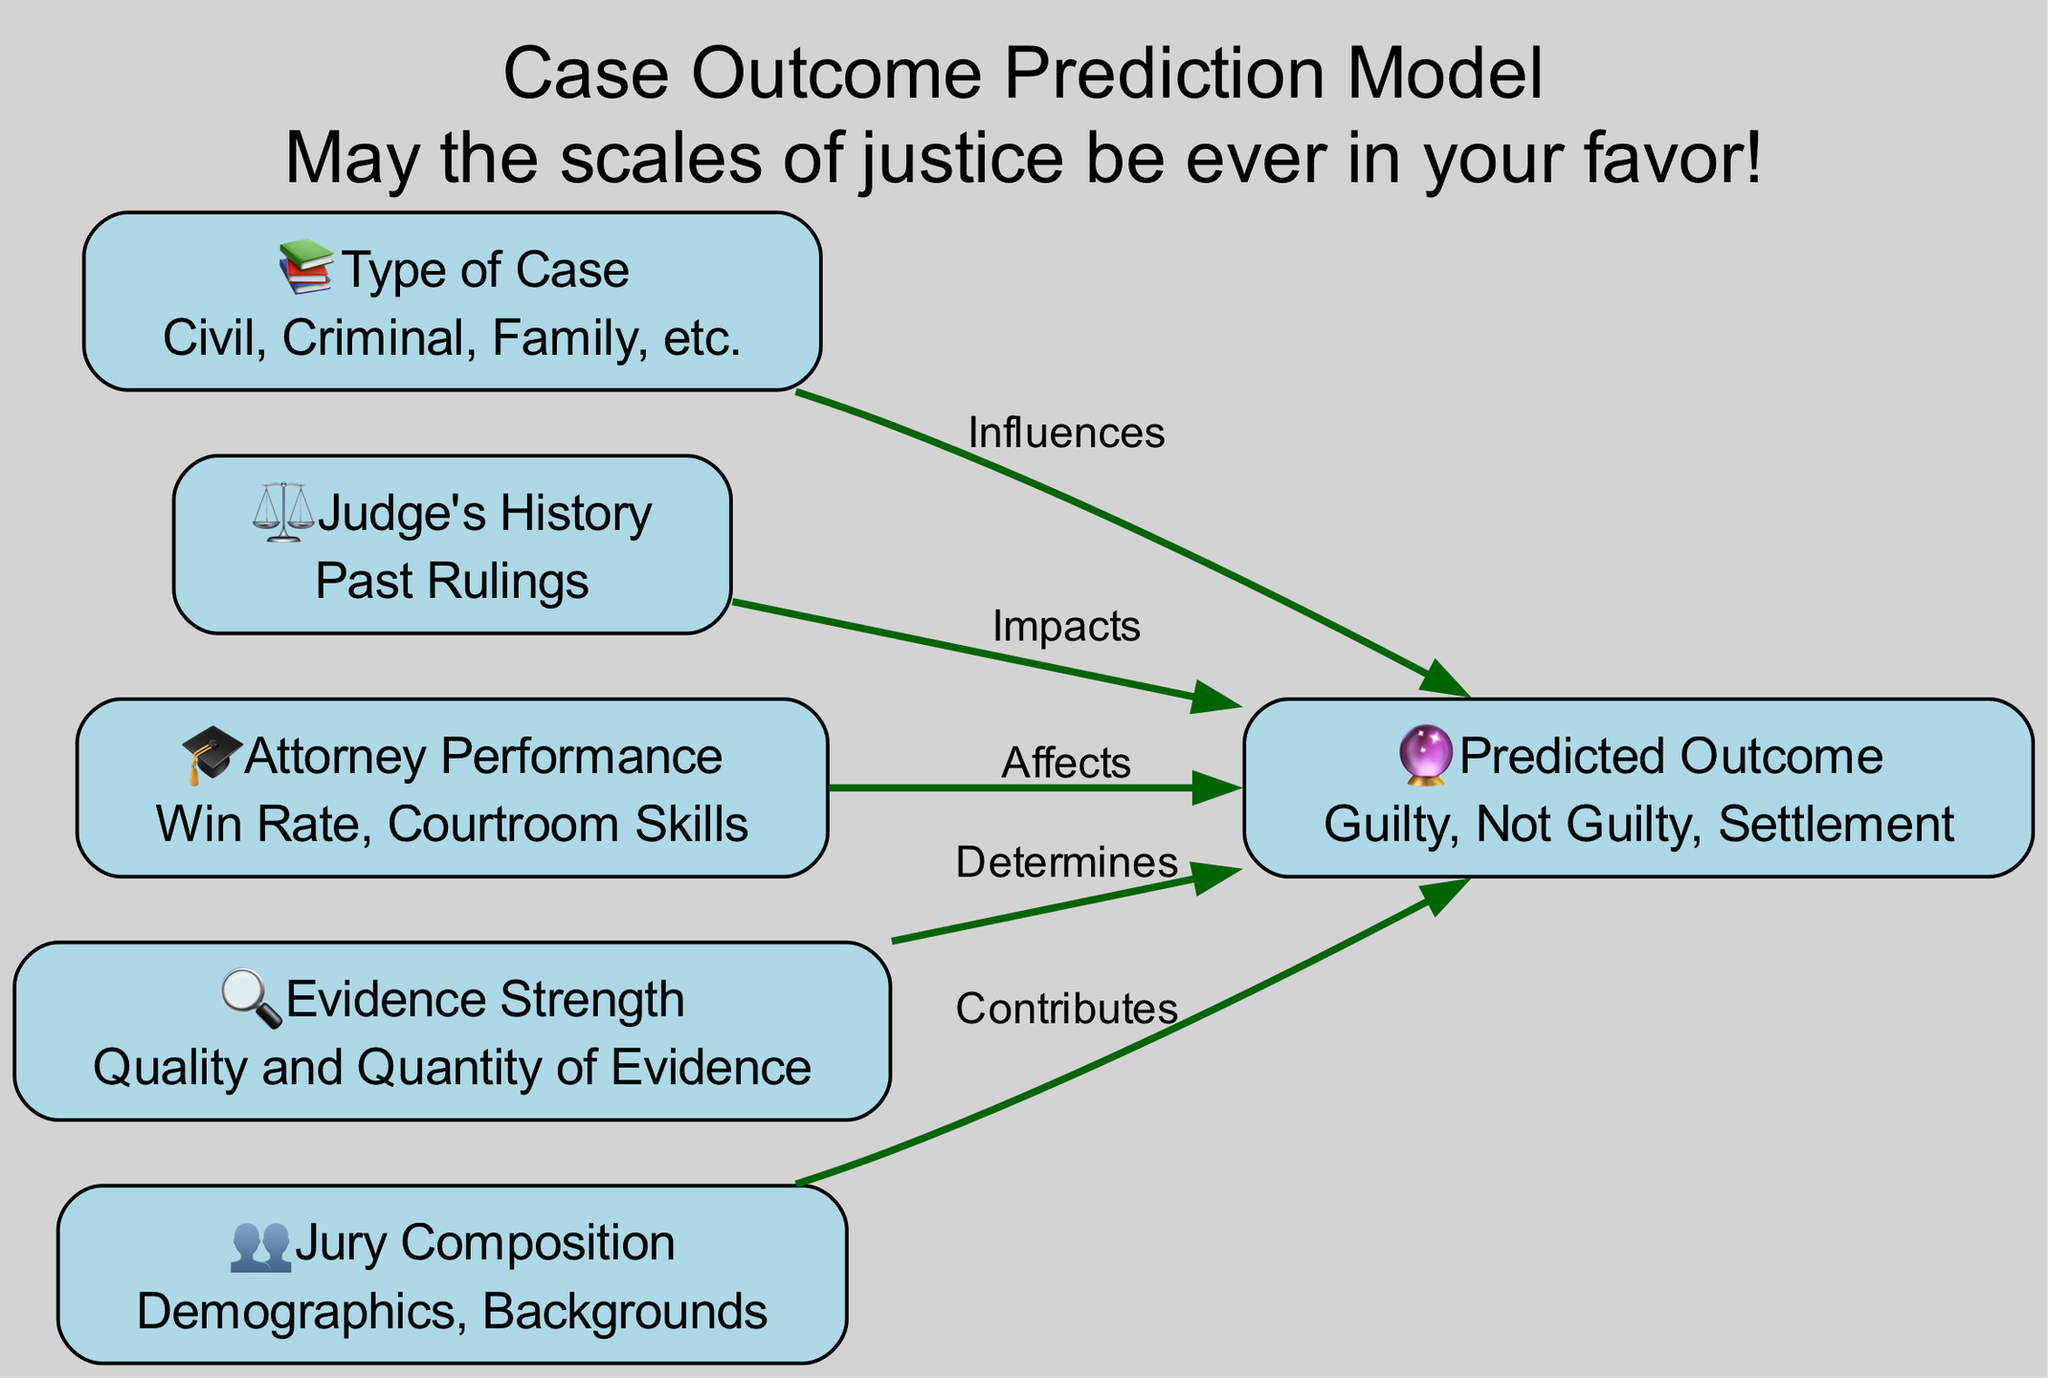What are the types of cases represented in the diagram? The diagram depicts the "Type of Case" node, which indicates different categories like Civil, Criminal, and Family. These types are directly listed within the node's description.
Answer: Civil, Criminal, Family How many nodes are present in the diagram? By counting the distinct nodes listed, we identify six nodes: type of case, judge's history, attorney performance, evidence strength, jury composition, and predicted outcome.
Answer: 6 Which node has an icon of a gavel? The "Judge's History" node is represented with the icon of a gavel (⚖️), indicating its focus on past rulings and their influence on case outcomes.
Answer: Judge's History What influences the case outcome according to the diagram? From the edges leading to the "Predicted Outcome" node, "Type of Case," "Judge's History," "Attorney Performance," "Evidence Strength," and "Jury Composition" all influence the predicted outcome of a case.
Answer: Type of Case, Judge's History, Attorney Performance, Evidence Strength, Jury Composition What determines the predicted outcome the most? Among the influencing nodes, "Evidence Strength" is explicitly labeled as determining the predicted outcome, highlighting its critical role in legal case evaluations.
Answer: Evidence Strength Which node contributes to the predicted outcome regarding demographics? The "Jury Composition" node focuses on demographics and backgrounds, indicating how these factors contribute to the predicted outcome of legal cases.
Answer: Jury Composition What is the relationship between attorney performance and case outcome? The edge from "Attorney Performance" to "Predicted Outcome" is labeled "Affects," indicating that the performance of the attorney has a direct effect on the outcome of the case.
Answer: Affects How does the judge's history impact the case outcome? The edge labeled "Impacts" indicates that the "Judge's History" directly influences the predicted outcome, emphasizing the importance of a judge's past rulings on current cases.
Answer: Impacts What is the predicted outcome represented in the diagram? The diagram clearly defines the "Predicted Outcome" node, which encompasses outcomes like Guilty, Not Guilty, and Settlement.
Answer: Guilty, Not Guilty, Settlement 